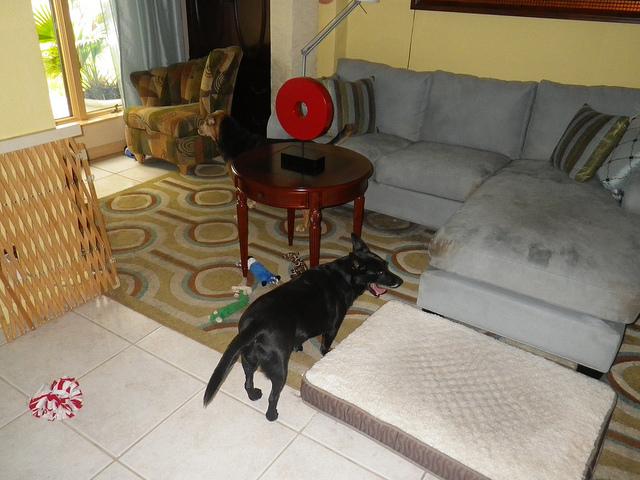Is the gate in the room?
Be succinct. Yes. What propped up against the wall?
Write a very short answer. Gate. Is there a view of the outdoors?
Be succinct. Yes. 